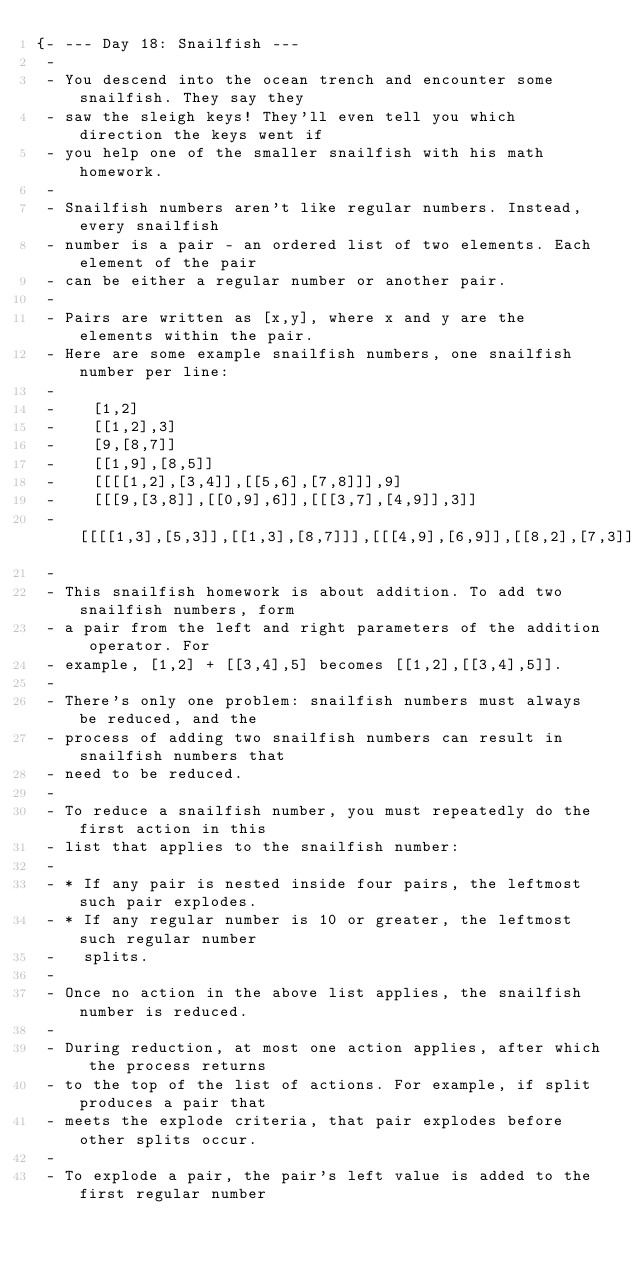Convert code to text. <code><loc_0><loc_0><loc_500><loc_500><_Haskell_>{- --- Day 18: Snailfish ---
 -
 - You descend into the ocean trench and encounter some snailfish. They say they
 - saw the sleigh keys! They'll even tell you which direction the keys went if
 - you help one of the smaller snailfish with his math homework.
 -
 - Snailfish numbers aren't like regular numbers. Instead, every snailfish
 - number is a pair - an ordered list of two elements. Each element of the pair
 - can be either a regular number or another pair.
 -
 - Pairs are written as [x,y], where x and y are the elements within the pair.
 - Here are some example snailfish numbers, one snailfish number per line:
 -
 -    [1,2]
 -    [[1,2],3]
 -    [9,[8,7]]
 -    [[1,9],[8,5]]
 -    [[[[1,2],[3,4]],[[5,6],[7,8]]],9]
 -    [[[9,[3,8]],[[0,9],6]],[[[3,7],[4,9]],3]]
 -    [[[[1,3],[5,3]],[[1,3],[8,7]]],[[[4,9],[6,9]],[[8,2],[7,3]]]]
 -
 - This snailfish homework is about addition. To add two snailfish numbers, form
 - a pair from the left and right parameters of the addition operator. For
 - example, [1,2] + [[3,4],5] becomes [[1,2],[[3,4],5]].
 -
 - There's only one problem: snailfish numbers must always be reduced, and the
 - process of adding two snailfish numbers can result in snailfish numbers that
 - need to be reduced.
 -
 - To reduce a snailfish number, you must repeatedly do the first action in this
 - list that applies to the snailfish number:
 -
 - * If any pair is nested inside four pairs, the leftmost such pair explodes.
 - * If any regular number is 10 or greater, the leftmost such regular number
 -   splits.
 -
 - Once no action in the above list applies, the snailfish number is reduced.
 -
 - During reduction, at most one action applies, after which the process returns
 - to the top of the list of actions. For example, if split produces a pair that
 - meets the explode criteria, that pair explodes before other splits occur.
 -
 - To explode a pair, the pair's left value is added to the first regular number</code> 